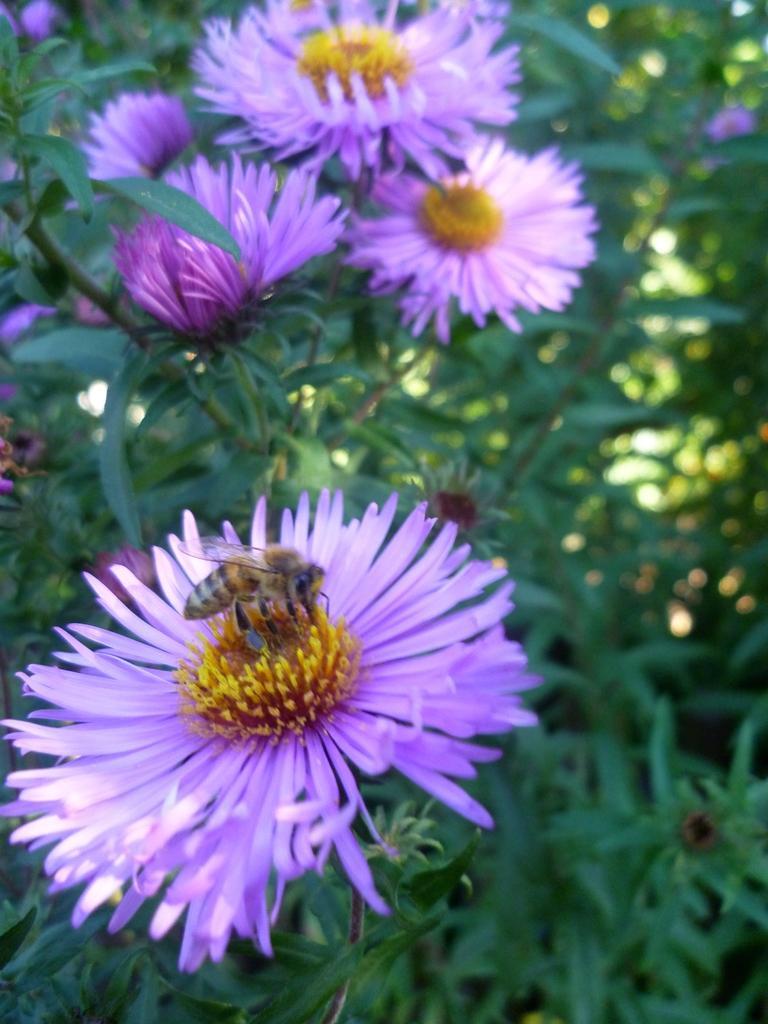Please provide a concise description of this image. In this image we can see there are flowers and plants, on the one of the flower there is a honey bee. 